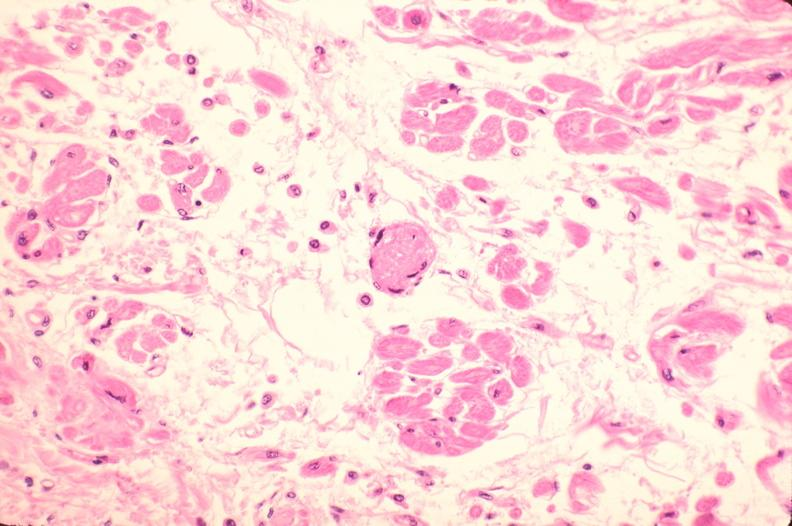s nipple duplication present?
Answer the question using a single word or phrase. No 